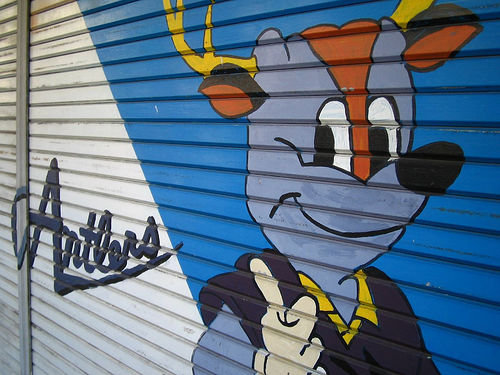<image>
Can you confirm if the antler is on the wall? Yes. Looking at the image, I can see the antler is positioned on top of the wall, with the wall providing support. 